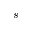Convert formula to latex. <formula><loc_0><loc_0><loc_500><loc_500>s</formula> 